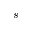Convert formula to latex. <formula><loc_0><loc_0><loc_500><loc_500>s</formula> 